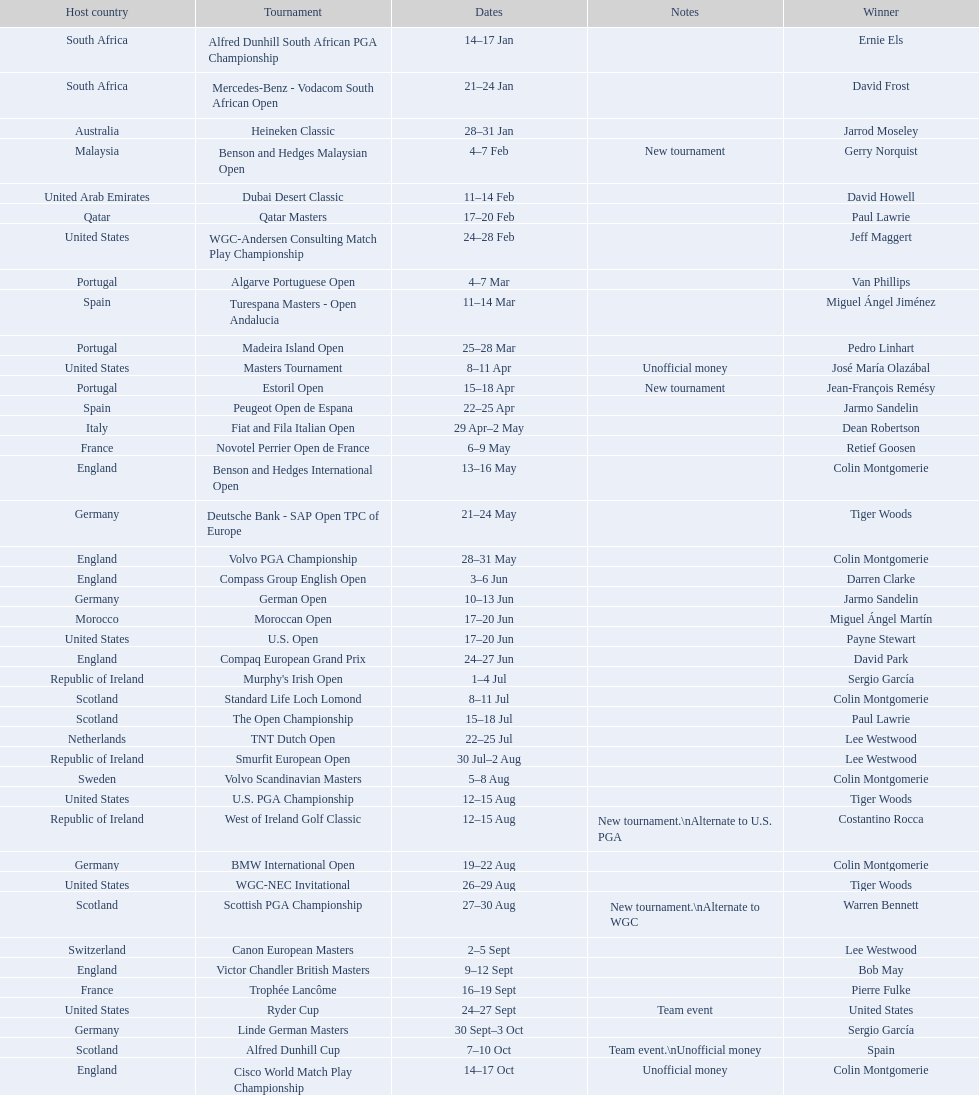Does any country have more than 5 winners? Yes. Write the full table. {'header': ['Host country', 'Tournament', 'Dates', 'Notes', 'Winner'], 'rows': [['South Africa', 'Alfred Dunhill South African PGA Championship', '14–17\xa0Jan', '', 'Ernie Els'], ['South Africa', 'Mercedes-Benz - Vodacom South African Open', '21–24\xa0Jan', '', 'David Frost'], ['Australia', 'Heineken Classic', '28–31\xa0Jan', '', 'Jarrod Moseley'], ['Malaysia', 'Benson and Hedges Malaysian Open', '4–7\xa0Feb', 'New tournament', 'Gerry Norquist'], ['United Arab Emirates', 'Dubai Desert Classic', '11–14\xa0Feb', '', 'David Howell'], ['Qatar', 'Qatar Masters', '17–20\xa0Feb', '', 'Paul Lawrie'], ['United States', 'WGC-Andersen Consulting Match Play Championship', '24–28\xa0Feb', '', 'Jeff Maggert'], ['Portugal', 'Algarve Portuguese Open', '4–7\xa0Mar', '', 'Van Phillips'], ['Spain', 'Turespana Masters - Open Andalucia', '11–14\xa0Mar', '', 'Miguel Ángel Jiménez'], ['Portugal', 'Madeira Island Open', '25–28\xa0Mar', '', 'Pedro Linhart'], ['United States', 'Masters Tournament', '8–11\xa0Apr', 'Unofficial money', 'José María Olazábal'], ['Portugal', 'Estoril Open', '15–18\xa0Apr', 'New tournament', 'Jean-François Remésy'], ['Spain', 'Peugeot Open de Espana', '22–25\xa0Apr', '', 'Jarmo Sandelin'], ['Italy', 'Fiat and Fila Italian Open', '29\xa0Apr–2\xa0May', '', 'Dean Robertson'], ['France', 'Novotel Perrier Open de France', '6–9\xa0May', '', 'Retief Goosen'], ['England', 'Benson and Hedges International Open', '13–16\xa0May', '', 'Colin Montgomerie'], ['Germany', 'Deutsche Bank - SAP Open TPC of Europe', '21–24\xa0May', '', 'Tiger Woods'], ['England', 'Volvo PGA Championship', '28–31\xa0May', '', 'Colin Montgomerie'], ['England', 'Compass Group English Open', '3–6\xa0Jun', '', 'Darren Clarke'], ['Germany', 'German Open', '10–13\xa0Jun', '', 'Jarmo Sandelin'], ['Morocco', 'Moroccan Open', '17–20\xa0Jun', '', 'Miguel Ángel Martín'], ['United States', 'U.S. Open', '17–20\xa0Jun', '', 'Payne Stewart'], ['England', 'Compaq European Grand Prix', '24–27\xa0Jun', '', 'David Park'], ['Republic of Ireland', "Murphy's Irish Open", '1–4\xa0Jul', '', 'Sergio García'], ['Scotland', 'Standard Life Loch Lomond', '8–11\xa0Jul', '', 'Colin Montgomerie'], ['Scotland', 'The Open Championship', '15–18\xa0Jul', '', 'Paul Lawrie'], ['Netherlands', 'TNT Dutch Open', '22–25\xa0Jul', '', 'Lee Westwood'], ['Republic of Ireland', 'Smurfit European Open', '30\xa0Jul–2\xa0Aug', '', 'Lee Westwood'], ['Sweden', 'Volvo Scandinavian Masters', '5–8\xa0Aug', '', 'Colin Montgomerie'], ['United States', 'U.S. PGA Championship', '12–15\xa0Aug', '', 'Tiger Woods'], ['Republic of Ireland', 'West of Ireland Golf Classic', '12–15\xa0Aug', 'New tournament.\\nAlternate to U.S. PGA', 'Costantino Rocca'], ['Germany', 'BMW International Open', '19–22\xa0Aug', '', 'Colin Montgomerie'], ['United States', 'WGC-NEC Invitational', '26–29\xa0Aug', '', 'Tiger Woods'], ['Scotland', 'Scottish PGA Championship', '27–30\xa0Aug', 'New tournament.\\nAlternate to WGC', 'Warren Bennett'], ['Switzerland', 'Canon European Masters', '2–5\xa0Sept', '', 'Lee Westwood'], ['England', 'Victor Chandler British Masters', '9–12\xa0Sept', '', 'Bob May'], ['France', 'Trophée Lancôme', '16–19\xa0Sept', '', 'Pierre Fulke'], ['United States', 'Ryder Cup', '24–27\xa0Sept', 'Team event', 'United States'], ['Germany', 'Linde German Masters', '30\xa0Sept–3\xa0Oct', '', 'Sergio García'], ['Scotland', 'Alfred Dunhill Cup', '7–10\xa0Oct', 'Team event.\\nUnofficial money', 'Spain'], ['England', 'Cisco World Match Play Championship', '14–17\xa0Oct', 'Unofficial money', 'Colin Montgomerie'], ['Spain', 'Sarazen World Open', '14–17\xa0Oct', 'New tournament', 'Thomas Bjørn'], ['Belgium', 'Belgacom Open', '21–24\xa0Oct', '', 'Robert Karlsson'], ['Spain', 'Volvo Masters', '28–31\xa0Oct', '', 'Miguel Ángel Jiménez'], ['Spain', 'WGC-American Express Championship', '4–7\xa0Nov', '', 'Tiger Woods'], ['Malaysia', 'World Cup of Golf', '18–21\xa0Nov', 'Team event.\\nUnofficial money', 'United States']]} 